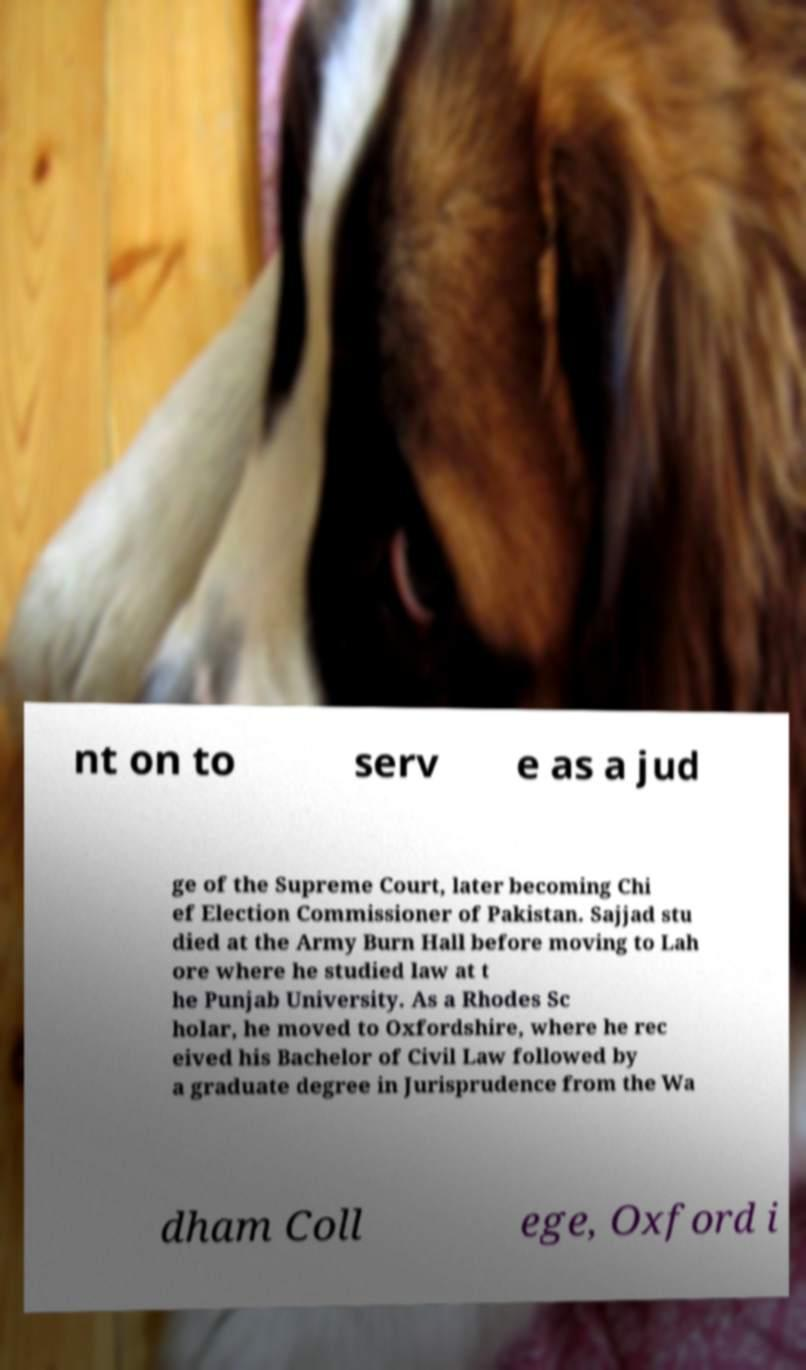Please identify and transcribe the text found in this image. nt on to serv e as a jud ge of the Supreme Court, later becoming Chi ef Election Commissioner of Pakistan. Sajjad stu died at the Army Burn Hall before moving to Lah ore where he studied law at t he Punjab University. As a Rhodes Sc holar, he moved to Oxfordshire, where he rec eived his Bachelor of Civil Law followed by a graduate degree in Jurisprudence from the Wa dham Coll ege, Oxford i 